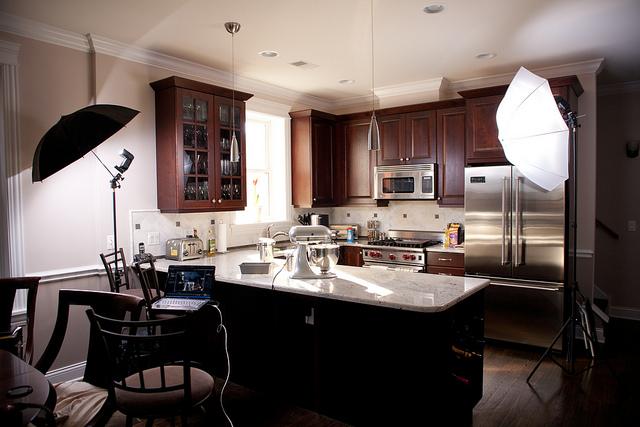Is the lighting in this room typical for an average household?
Give a very brief answer. No. Does the refrigerator have a bottom drawer?
Short answer required. Yes. If a burglar stole food from the refrigerator, what incriminating evidence might she leave behind?
Quick response, please. Fingerprints. 